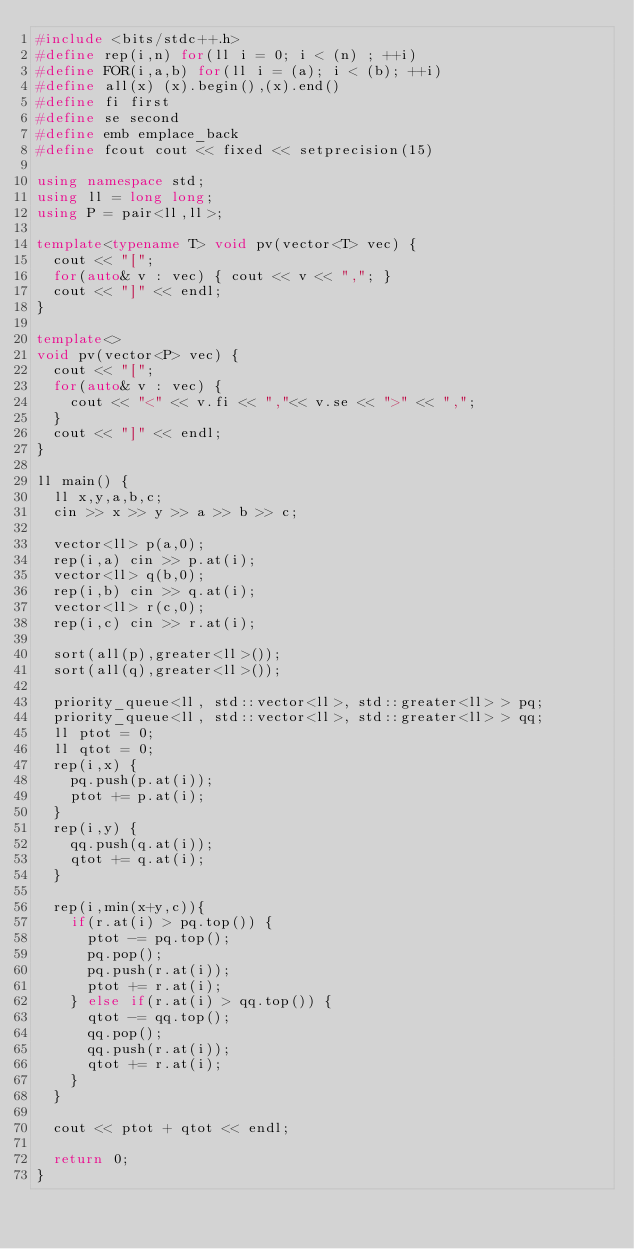<code> <loc_0><loc_0><loc_500><loc_500><_C++_>#include <bits/stdc++.h>
#define rep(i,n) for(ll i = 0; i < (n) ; ++i)
#define FOR(i,a,b) for(ll i = (a); i < (b); ++i)
#define all(x) (x).begin(),(x).end()
#define fi first
#define se second
#define emb emplace_back
#define fcout cout << fixed << setprecision(15)

using namespace std;
using ll = long long;
using P = pair<ll,ll>;

template<typename T> void pv(vector<T> vec) {
  cout << "[";
  for(auto& v : vec) { cout << v << ","; }
  cout << "]" << endl;
}

template<>
void pv(vector<P> vec) {
  cout << "[";
  for(auto& v : vec) {
    cout << "<" << v.fi << ","<< v.se << ">" << ",";
  }
  cout << "]" << endl;
}

ll main() {
  ll x,y,a,b,c;
  cin >> x >> y >> a >> b >> c;

  vector<ll> p(a,0);
  rep(i,a) cin >> p.at(i);
  vector<ll> q(b,0);
  rep(i,b) cin >> q.at(i);
  vector<ll> r(c,0);
  rep(i,c) cin >> r.at(i);

  sort(all(p),greater<ll>());
  sort(all(q),greater<ll>());

  priority_queue<ll, std::vector<ll>, std::greater<ll> > pq;
  priority_queue<ll, std::vector<ll>, std::greater<ll> > qq;
  ll ptot = 0;
  ll qtot = 0;
  rep(i,x) {
    pq.push(p.at(i));
    ptot += p.at(i);
  }
  rep(i,y) {
    qq.push(q.at(i));
    qtot += q.at(i);
  }

  rep(i,min(x+y,c)){
    if(r.at(i) > pq.top()) {
      ptot -= pq.top();
      pq.pop();
      pq.push(r.at(i));
      ptot += r.at(i);
    } else if(r.at(i) > qq.top()) {
      qtot -= qq.top();
      qq.pop();
      qq.push(r.at(i));
      qtot += r.at(i);
    }
  }

  cout << ptot + qtot << endl;

  return 0;
}
</code> 